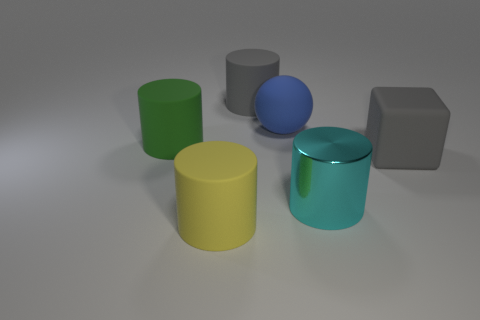Add 3 small brown matte spheres. How many objects exist? 9 Subtract all balls. How many objects are left? 5 Subtract 0 brown cylinders. How many objects are left? 6 Subtract all small red metallic balls. Subtract all large cyan cylinders. How many objects are left? 5 Add 2 large yellow matte cylinders. How many large yellow matte cylinders are left? 3 Add 4 big blue things. How many big blue things exist? 5 